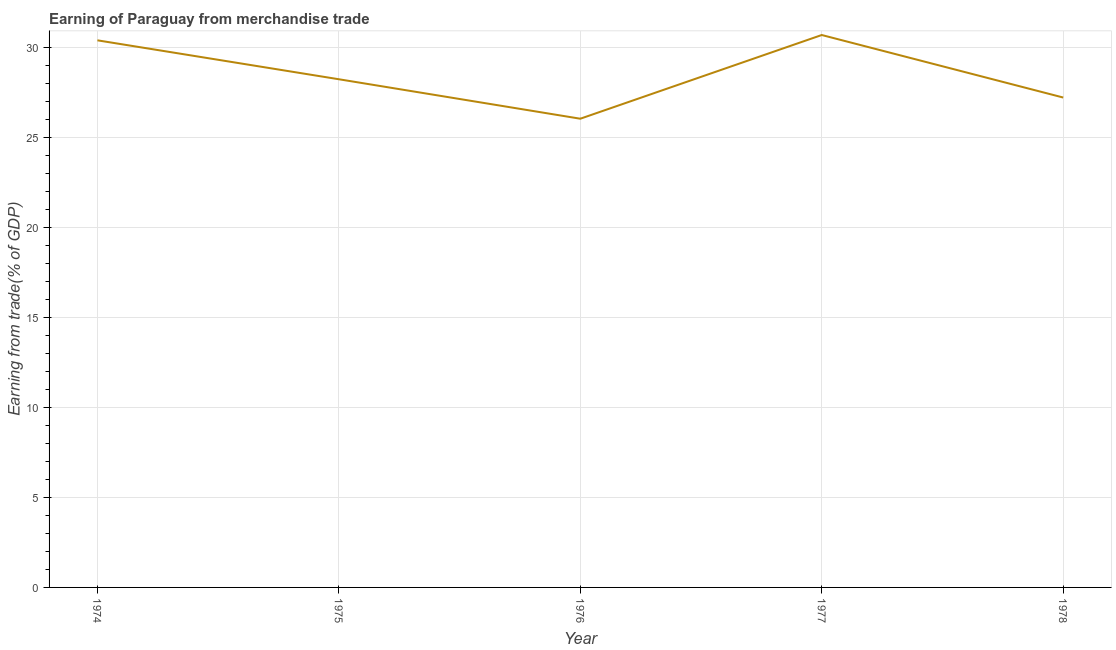What is the earning from merchandise trade in 1975?
Provide a succinct answer. 28.25. Across all years, what is the maximum earning from merchandise trade?
Keep it short and to the point. 30.71. Across all years, what is the minimum earning from merchandise trade?
Your answer should be very brief. 26.05. In which year was the earning from merchandise trade minimum?
Keep it short and to the point. 1976. What is the sum of the earning from merchandise trade?
Your response must be concise. 142.65. What is the difference between the earning from merchandise trade in 1974 and 1976?
Your answer should be very brief. 4.36. What is the average earning from merchandise trade per year?
Your answer should be compact. 28.53. What is the median earning from merchandise trade?
Provide a short and direct response. 28.25. Do a majority of the years between 1974 and 1978 (inclusive) have earning from merchandise trade greater than 11 %?
Your answer should be compact. Yes. What is the ratio of the earning from merchandise trade in 1975 to that in 1978?
Keep it short and to the point. 1.04. Is the earning from merchandise trade in 1976 less than that in 1977?
Provide a short and direct response. Yes. Is the difference between the earning from merchandise trade in 1975 and 1978 greater than the difference between any two years?
Offer a terse response. No. What is the difference between the highest and the second highest earning from merchandise trade?
Provide a succinct answer. 0.3. Is the sum of the earning from merchandise trade in 1974 and 1978 greater than the maximum earning from merchandise trade across all years?
Your answer should be very brief. Yes. What is the difference between the highest and the lowest earning from merchandise trade?
Offer a very short reply. 4.65. In how many years, is the earning from merchandise trade greater than the average earning from merchandise trade taken over all years?
Your response must be concise. 2. Does the earning from merchandise trade monotonically increase over the years?
Give a very brief answer. No. How many lines are there?
Ensure brevity in your answer.  1. How many years are there in the graph?
Ensure brevity in your answer.  5. What is the difference between two consecutive major ticks on the Y-axis?
Provide a short and direct response. 5. Are the values on the major ticks of Y-axis written in scientific E-notation?
Provide a short and direct response. No. Does the graph contain grids?
Provide a short and direct response. Yes. What is the title of the graph?
Your answer should be very brief. Earning of Paraguay from merchandise trade. What is the label or title of the X-axis?
Your answer should be compact. Year. What is the label or title of the Y-axis?
Make the answer very short. Earning from trade(% of GDP). What is the Earning from trade(% of GDP) of 1974?
Your answer should be very brief. 30.41. What is the Earning from trade(% of GDP) of 1975?
Offer a very short reply. 28.25. What is the Earning from trade(% of GDP) of 1976?
Keep it short and to the point. 26.05. What is the Earning from trade(% of GDP) in 1977?
Offer a very short reply. 30.71. What is the Earning from trade(% of GDP) in 1978?
Provide a succinct answer. 27.23. What is the difference between the Earning from trade(% of GDP) in 1974 and 1975?
Make the answer very short. 2.16. What is the difference between the Earning from trade(% of GDP) in 1974 and 1976?
Provide a short and direct response. 4.36. What is the difference between the Earning from trade(% of GDP) in 1974 and 1977?
Make the answer very short. -0.3. What is the difference between the Earning from trade(% of GDP) in 1974 and 1978?
Keep it short and to the point. 3.18. What is the difference between the Earning from trade(% of GDP) in 1975 and 1976?
Offer a terse response. 2.19. What is the difference between the Earning from trade(% of GDP) in 1975 and 1977?
Your answer should be compact. -2.46. What is the difference between the Earning from trade(% of GDP) in 1975 and 1978?
Your answer should be very brief. 1.02. What is the difference between the Earning from trade(% of GDP) in 1976 and 1977?
Give a very brief answer. -4.65. What is the difference between the Earning from trade(% of GDP) in 1976 and 1978?
Make the answer very short. -1.18. What is the difference between the Earning from trade(% of GDP) in 1977 and 1978?
Offer a terse response. 3.47. What is the ratio of the Earning from trade(% of GDP) in 1974 to that in 1975?
Your answer should be compact. 1.08. What is the ratio of the Earning from trade(% of GDP) in 1974 to that in 1976?
Your answer should be compact. 1.17. What is the ratio of the Earning from trade(% of GDP) in 1974 to that in 1978?
Provide a short and direct response. 1.12. What is the ratio of the Earning from trade(% of GDP) in 1975 to that in 1976?
Offer a very short reply. 1.08. What is the ratio of the Earning from trade(% of GDP) in 1976 to that in 1977?
Provide a short and direct response. 0.85. What is the ratio of the Earning from trade(% of GDP) in 1977 to that in 1978?
Your response must be concise. 1.13. 